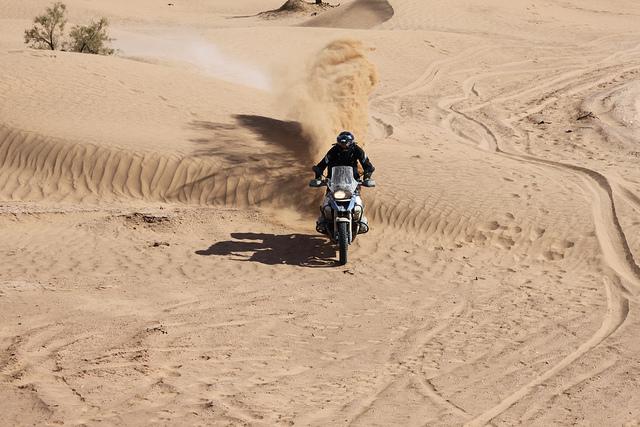What kind of terrain is this?
Concise answer only. Desert. Is he wearing a helmet?
Answer briefly. Yes. What is the man riding?
Give a very brief answer. Motorcycle. 